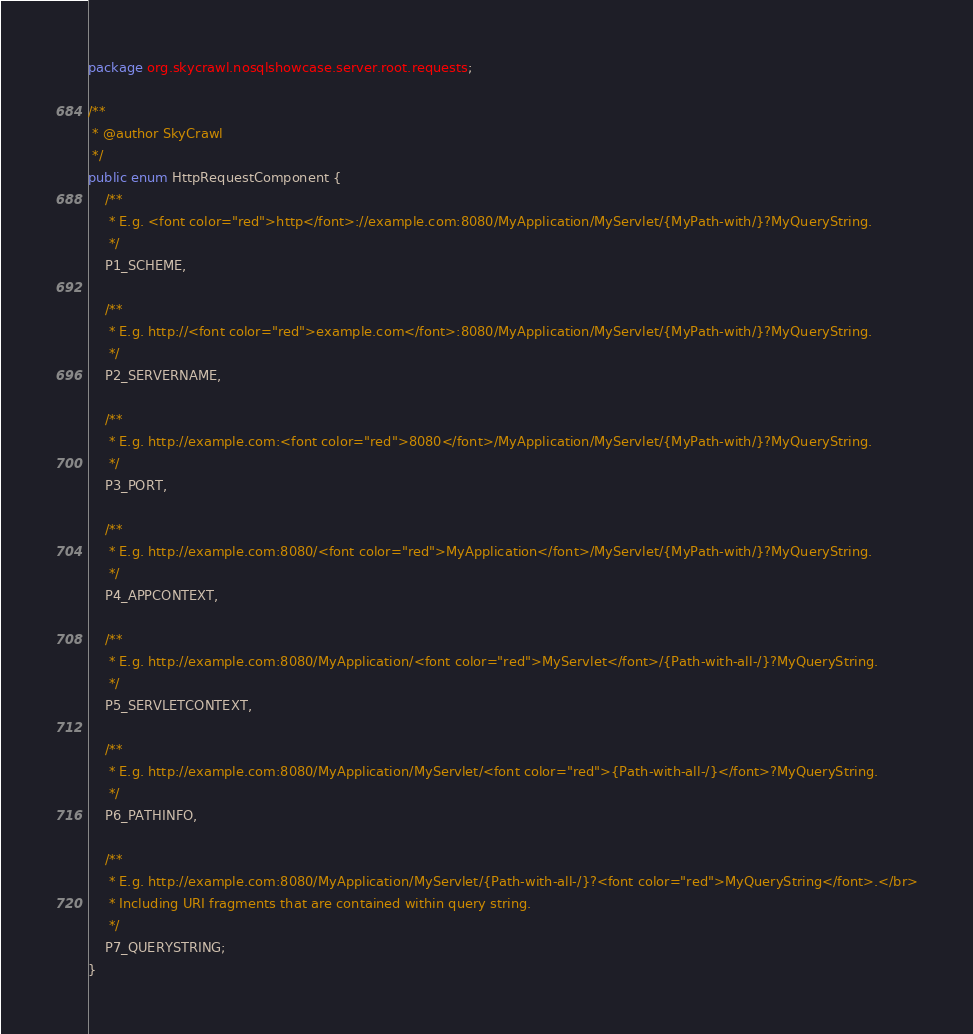<code> <loc_0><loc_0><loc_500><loc_500><_Java_>package org.skycrawl.nosqlshowcase.server.root.requests;

/**
 * @author SkyCrawl
 */
public enum HttpRequestComponent {
	/**
	 * E.g. <font color="red">http</font>://example.com:8080/MyApplication/MyServlet/{MyPath-with/}?MyQueryString.
	 */
	P1_SCHEME,

	/**
	 * E.g. http://<font color="red">example.com</font>:8080/MyApplication/MyServlet/{MyPath-with/}?MyQueryString.
	 */
	P2_SERVERNAME,

	/**
	 * E.g. http://example.com:<font color="red">8080</font>/MyApplication/MyServlet/{MyPath-with/}?MyQueryString. 
	 */
	P3_PORT,

	/**
	 * E.g. http://example.com:8080/<font color="red">MyApplication</font>/MyServlet/{MyPath-with/}?MyQueryString.
	 */
	P4_APPCONTEXT,

	/**
	 * E.g. http://example.com:8080/MyApplication/<font color="red">MyServlet</font>/{Path-with-all-/}?MyQueryString.
	 */
	P5_SERVLETCONTEXT,

	/**
	 * E.g. http://example.com:8080/MyApplication/MyServlet/<font color="red">{Path-with-all-/}</font>?MyQueryString.
	 */
	P6_PATHINFO,

	/**
	 * E.g. http://example.com:8080/MyApplication/MyServlet/{Path-with-all-/}?<font color="red">MyQueryString</font>.</br>
	 * Including URI fragments that are contained within query string.
	 */
	P7_QUERYSTRING;
}</code> 